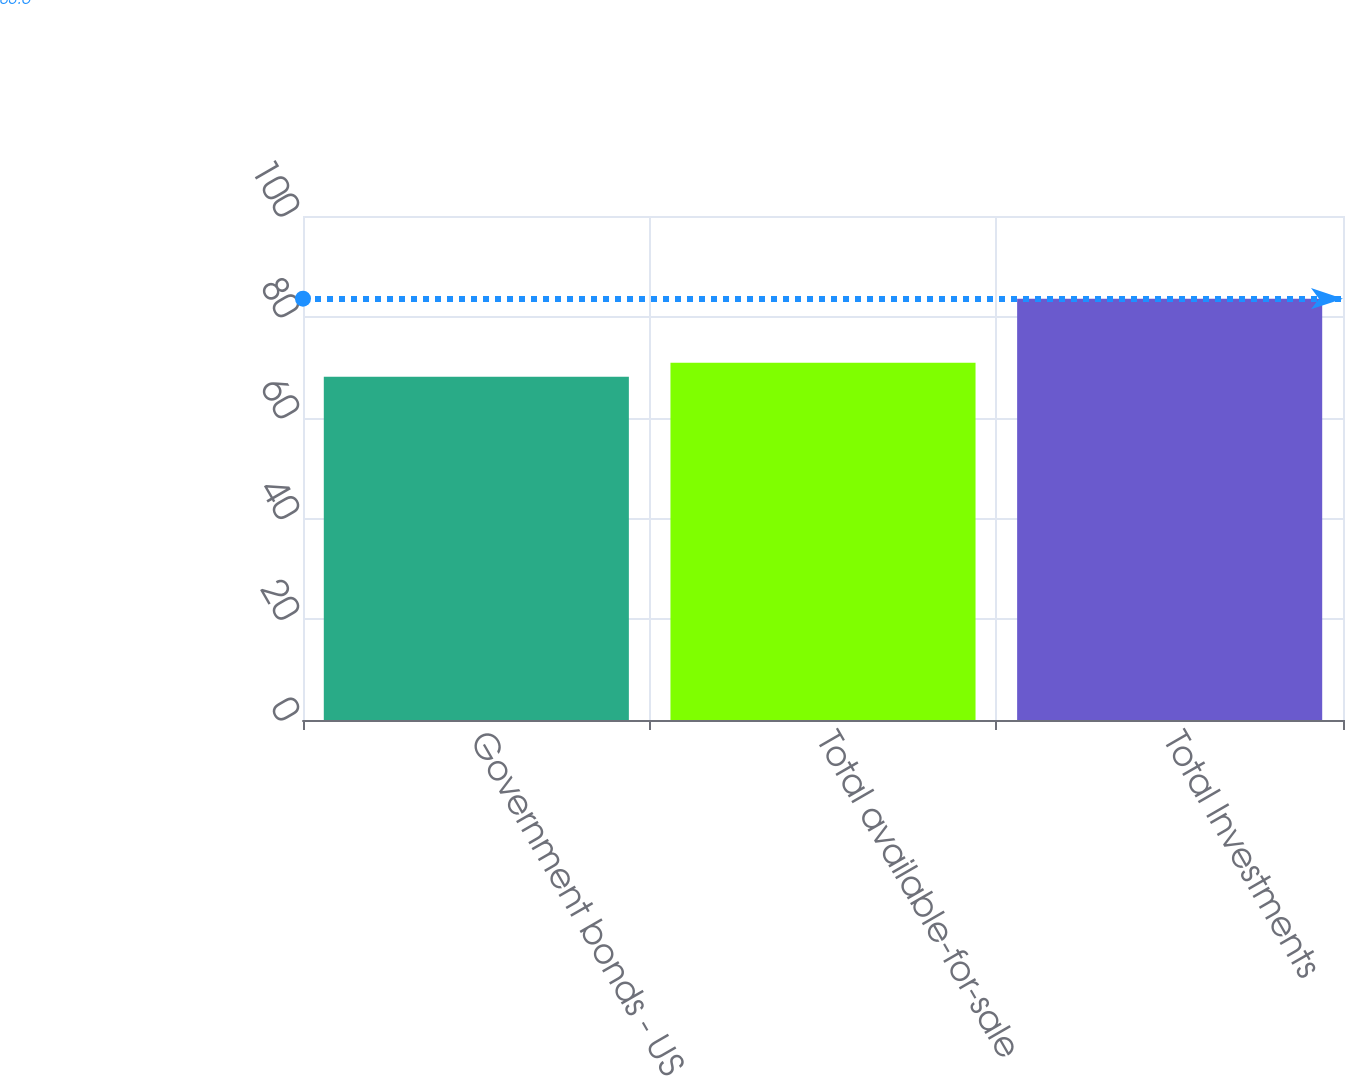Convert chart to OTSL. <chart><loc_0><loc_0><loc_500><loc_500><bar_chart><fcel>Government bonds - US<fcel>Total available-for-sale<fcel>Total Investments<nl><fcel>68.1<fcel>70.9<fcel>83.6<nl></chart> 